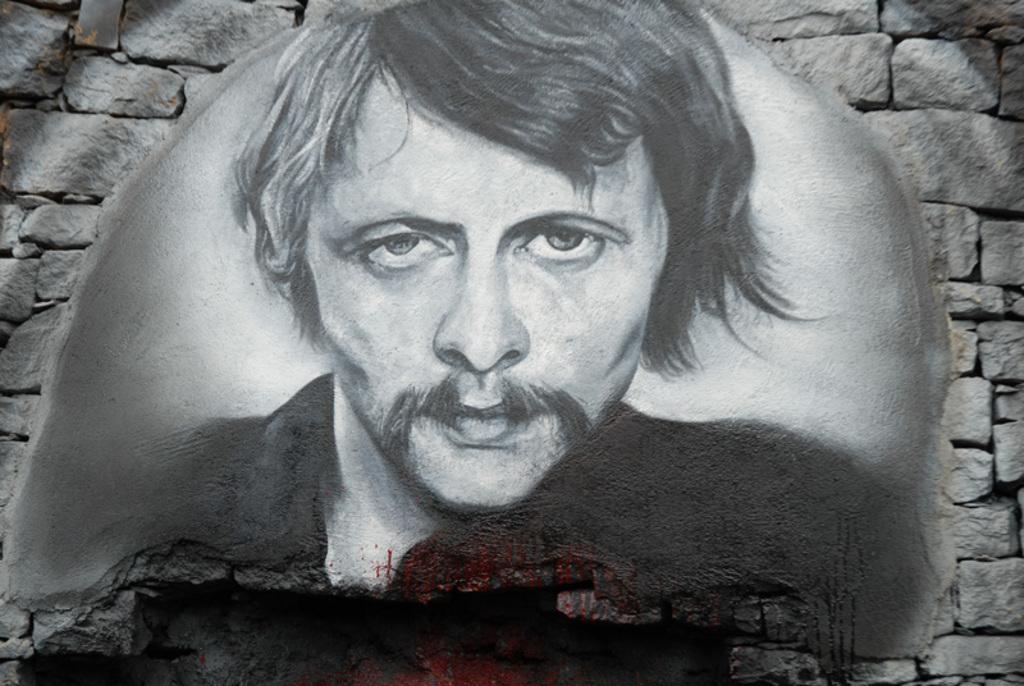Can you describe this image briefly? In this image there is a painting of a man in the middle. There is a stone wall around the painting. 